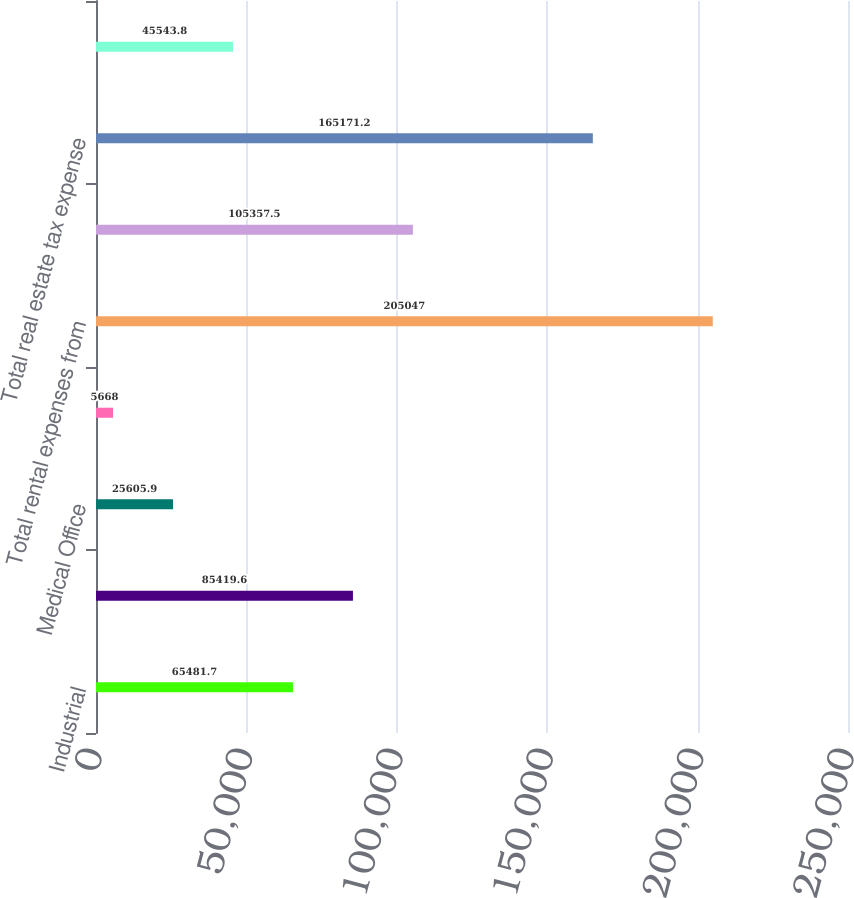<chart> <loc_0><loc_0><loc_500><loc_500><bar_chart><fcel>Industrial<fcel>Office<fcel>Medical Office<fcel>Other<fcel>Total rental expenses from<fcel>Rental expenses from<fcel>Total real estate tax expense<fcel>Real estate tax expense from<nl><fcel>65481.7<fcel>85419.6<fcel>25605.9<fcel>5668<fcel>205047<fcel>105358<fcel>165171<fcel>45543.8<nl></chart> 